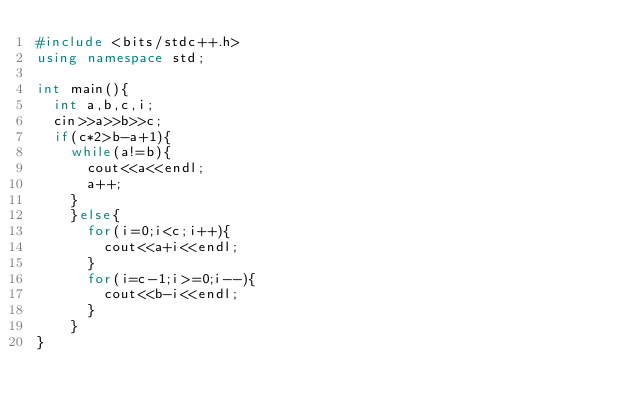Convert code to text. <code><loc_0><loc_0><loc_500><loc_500><_C++_>#include <bits/stdc++.h>
using namespace std;

int main(){
  int a,b,c,i;
  cin>>a>>b>>c;
  if(c*2>b-a+1){
    while(a!=b){
      cout<<a<<endl;
      a++;
    }
    }else{
      for(i=0;i<c;i++){
        cout<<a+i<<endl;
      }
      for(i=c-1;i>=0;i--){
        cout<<b-i<<endl;
      }
    }
}</code> 